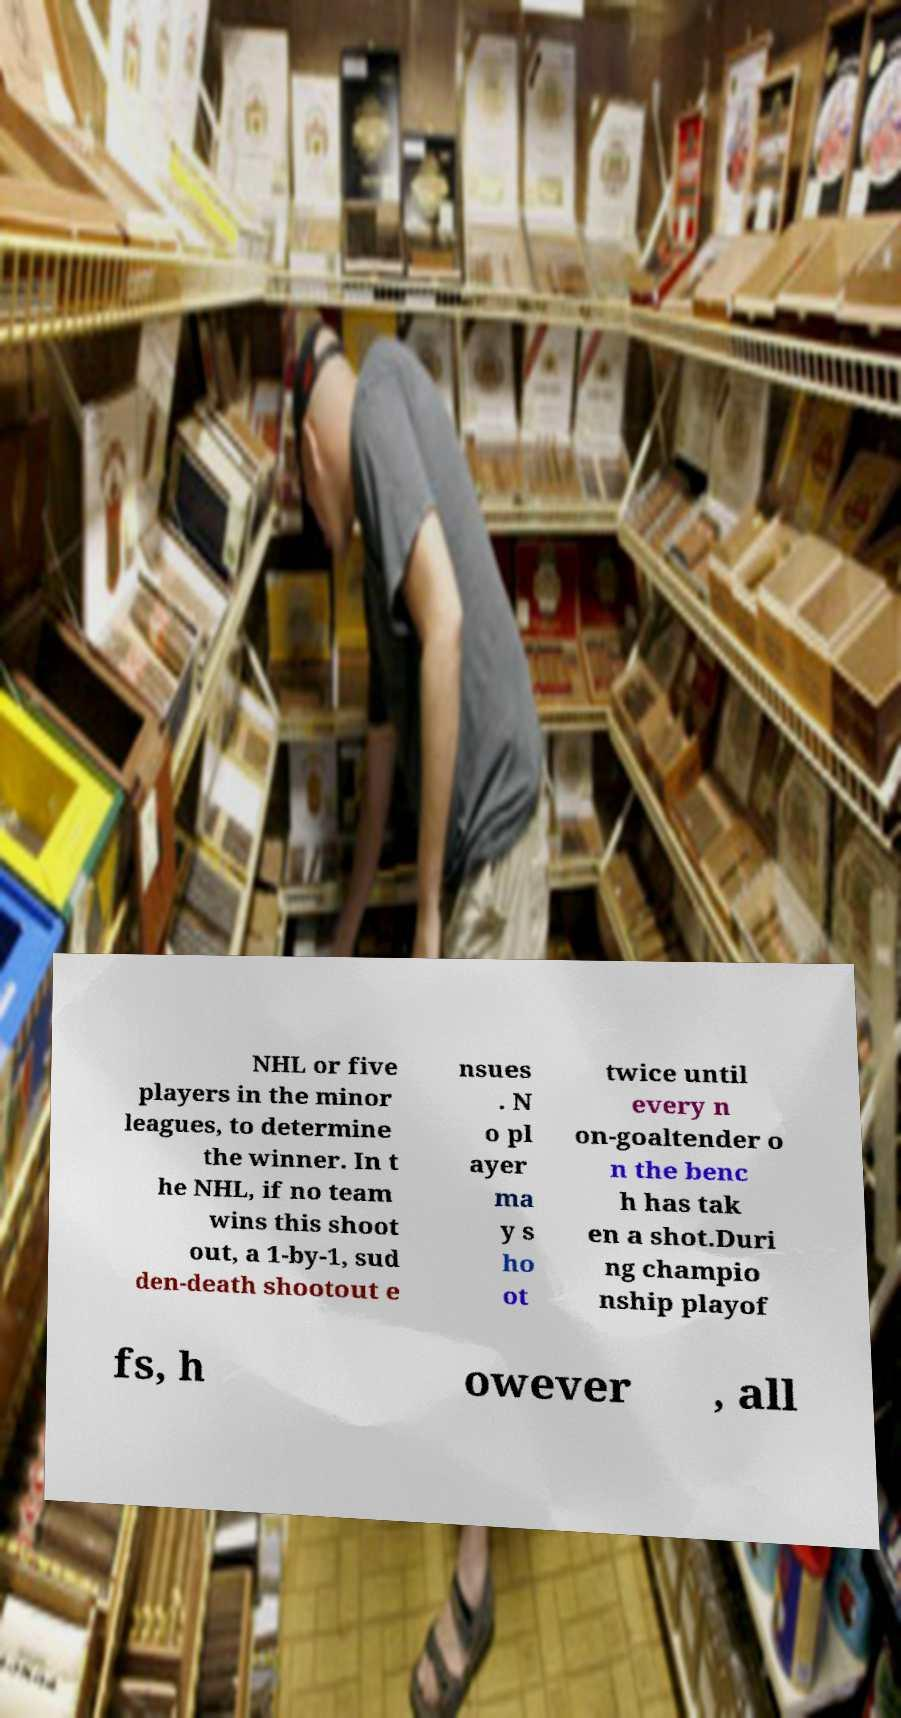There's text embedded in this image that I need extracted. Can you transcribe it verbatim? NHL or five players in the minor leagues, to determine the winner. In t he NHL, if no team wins this shoot out, a 1-by-1, sud den-death shootout e nsues . N o pl ayer ma y s ho ot twice until every n on-goaltender o n the benc h has tak en a shot.Duri ng champio nship playof fs, h owever , all 